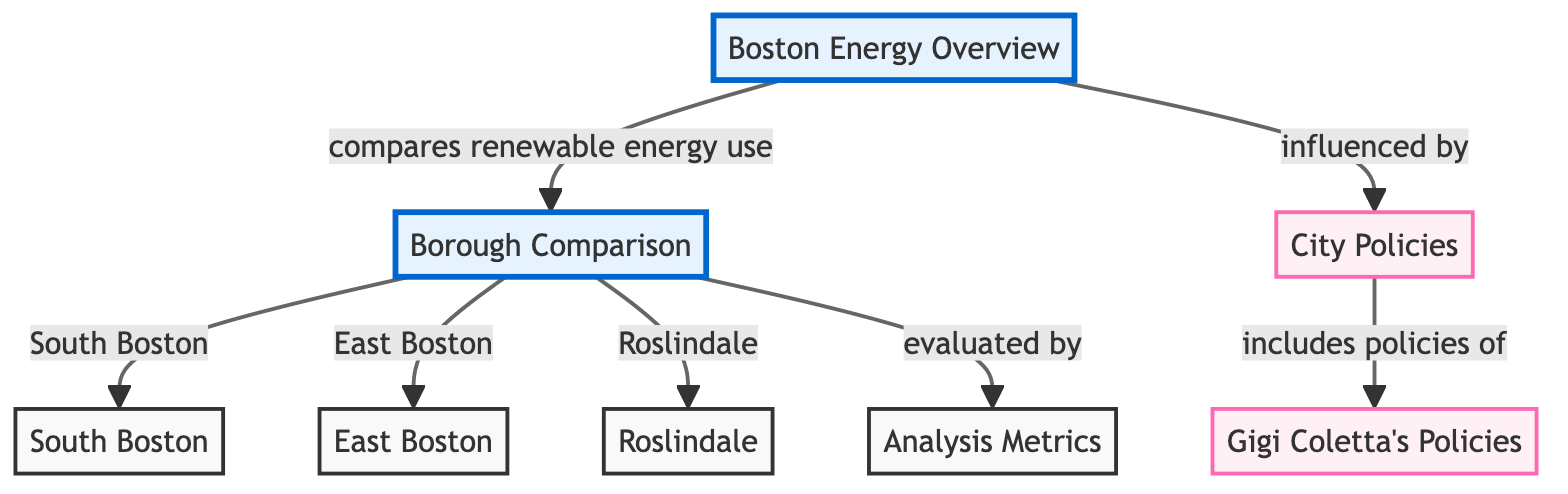What is the main focus of the diagram? The main focus of the diagram is on the comparative analysis of renewable energy utilization across different boroughs in Boston, highlighting the influence of public policies.
Answer: Comparative analysis of renewable energy utilization How many boroughs are compared in the diagram? The diagram compares three boroughs: South Boston, East Boston, and Roslindale. Counting the borough nodes provides the answer.
Answer: Three Which policy framework is the diagram influenced by? The diagram's focus on renewable energy usage is influenced by city policies, which include Gigi Coletta's policies. Tracing the connections from "Boston Energy Overview" leads to this conclusion.
Answer: City policies What does the borough comparison lead to in the diagram? The borough comparison evaluates renewable energy utilization using specific analysis metrics. Following the arrows from "Borough Comparison" shows this relationship.
Answer: Analysis metrics What role do Gigi Coletta's policies play in the diagram? Gigi Coletta's policies are included in the broader city policies, suggesting that they influence renewable energy utilization in Boston. This is illustrated by the connection between "City Policies" and "Gigi Coletta's Policies."
Answer: Influence on city policies 